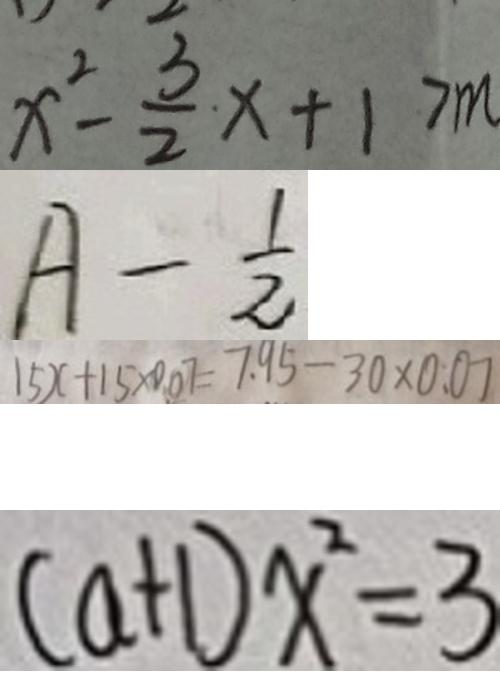<formula> <loc_0><loc_0><loc_500><loc_500>x ^ { 2 } - \frac { 3 } { 2 } x + 1 > m 
 A - \frac { 1 } { 2 } 
 1 5 x + 1 5 \times 0 . 0 7 = 7 . 9 5 - 3 0 \times 0 . 0 7 
 ( a + 1 ) x ^ { 2 } = 3</formula> 